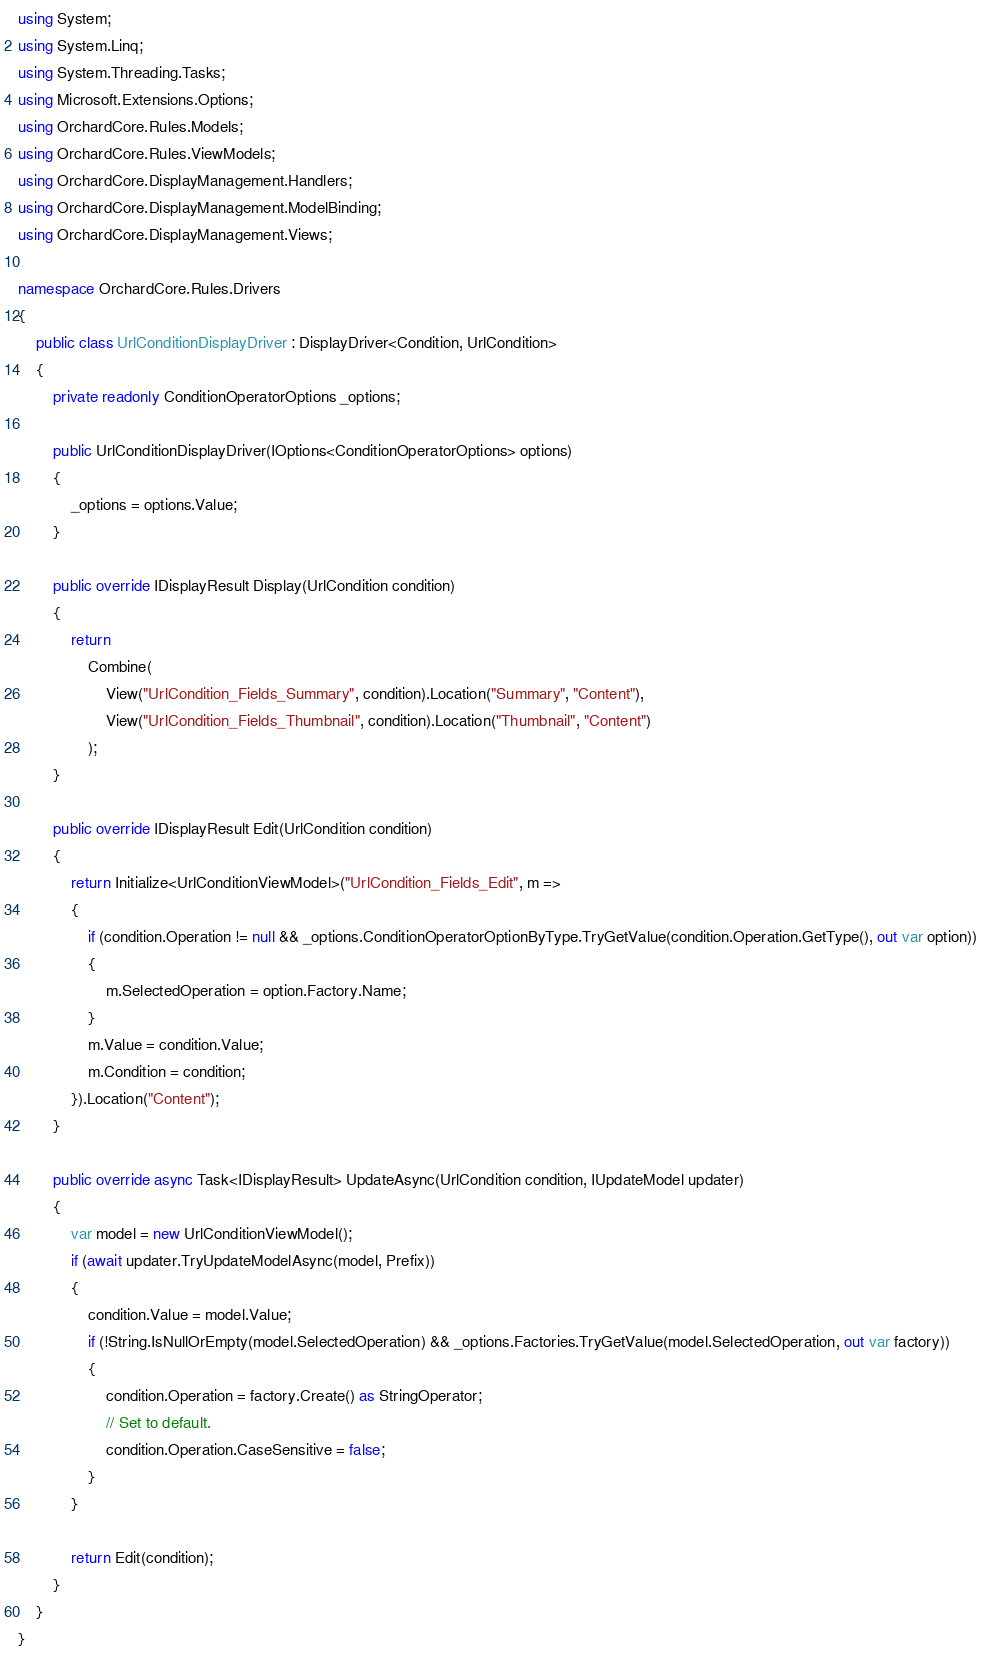Convert code to text. <code><loc_0><loc_0><loc_500><loc_500><_C#_>using System;
using System.Linq;
using System.Threading.Tasks;
using Microsoft.Extensions.Options;
using OrchardCore.Rules.Models;
using OrchardCore.Rules.ViewModels;
using OrchardCore.DisplayManagement.Handlers;
using OrchardCore.DisplayManagement.ModelBinding;
using OrchardCore.DisplayManagement.Views;

namespace OrchardCore.Rules.Drivers
{
    public class UrlConditionDisplayDriver : DisplayDriver<Condition, UrlCondition>
    {
        private readonly ConditionOperatorOptions _options;

        public UrlConditionDisplayDriver(IOptions<ConditionOperatorOptions> options)
        {
            _options = options.Value;
        }
        
        public override IDisplayResult Display(UrlCondition condition)
        {
            return
                Combine(
                    View("UrlCondition_Fields_Summary", condition).Location("Summary", "Content"),
                    View("UrlCondition_Fields_Thumbnail", condition).Location("Thumbnail", "Content")
                );
        }

        public override IDisplayResult Edit(UrlCondition condition)
        {
            return Initialize<UrlConditionViewModel>("UrlCondition_Fields_Edit", m =>
            {
                if (condition.Operation != null && _options.ConditionOperatorOptionByType.TryGetValue(condition.Operation.GetType(), out var option))
                {
                    m.SelectedOperation = option.Factory.Name;
                }
                m.Value = condition.Value;
                m.Condition = condition;
            }).Location("Content");
        }

        public override async Task<IDisplayResult> UpdateAsync(UrlCondition condition, IUpdateModel updater)
        {
            var model = new UrlConditionViewModel();
            if (await updater.TryUpdateModelAsync(model, Prefix))
            {
                condition.Value = model.Value;
                if (!String.IsNullOrEmpty(model.SelectedOperation) && _options.Factories.TryGetValue(model.SelectedOperation, out var factory))
                {
                    condition.Operation = factory.Create() as StringOperator;
                    // Set to default.
                    condition.Operation.CaseSensitive = false;
                }
            }

            return Edit(condition);
        }
    }
}
</code> 